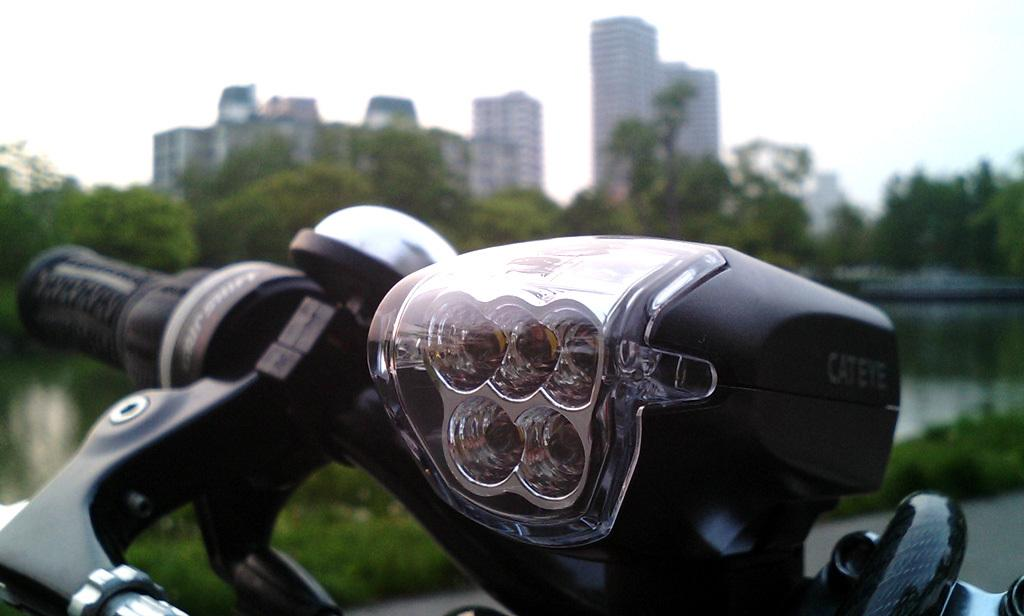What type of vehicle is partially visible in the image? There is a part of a motorcycle in the image. What can be seen in the distance behind the motorcycle? Trees, buildings, and a lake are visible in the background of the image. What is the condition of the sky in the image? Clouds are visible in the sky. What type of pen can be seen in the image? There is no pen present in the image. Is there an alley visible in the image? No, there is no alley visible in the image. 